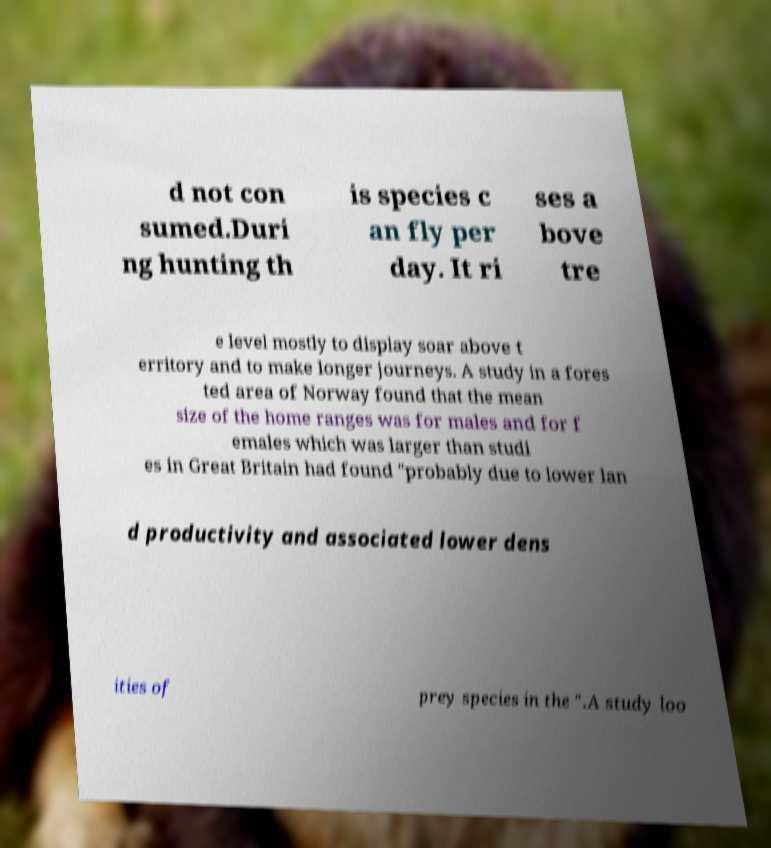Can you read and provide the text displayed in the image?This photo seems to have some interesting text. Can you extract and type it out for me? d not con sumed.Duri ng hunting th is species c an fly per day. It ri ses a bove tre e level mostly to display soar above t erritory and to make longer journeys. A study in a fores ted area of Norway found that the mean size of the home ranges was for males and for f emales which was larger than studi es in Great Britain had found "probably due to lower lan d productivity and associated lower dens ities of prey species in the ".A study loo 